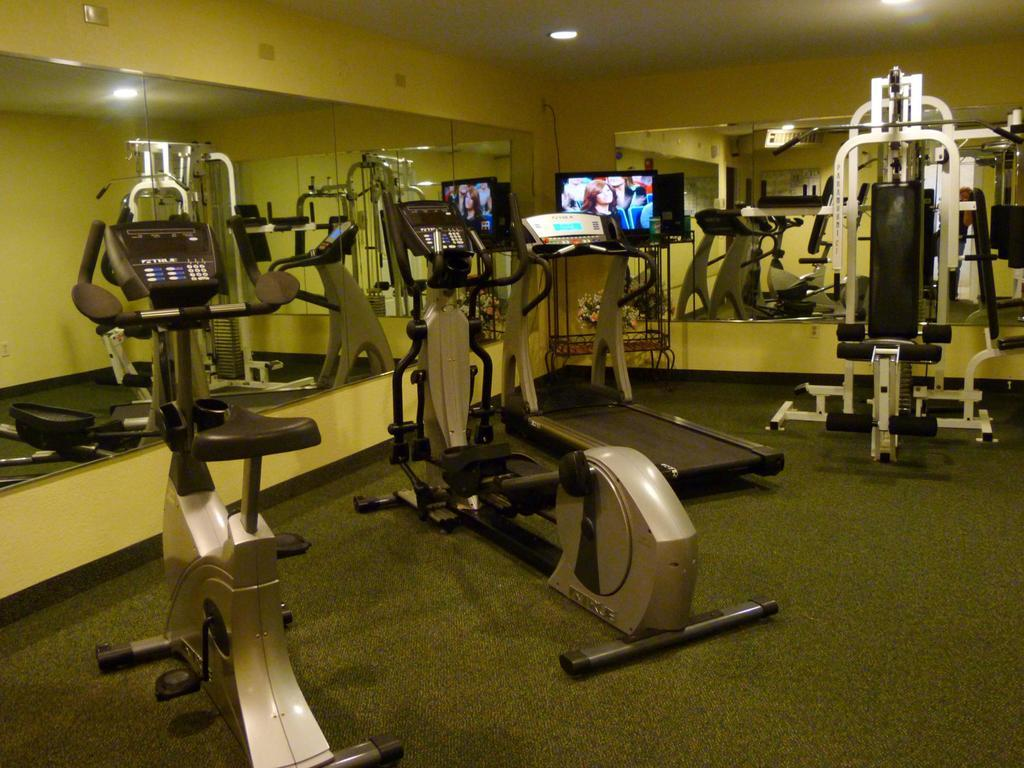What type of equipment is present in the image? There are exercise machines in the image. What electronic device can be seen in the image? There is a TV on a stand in the image. What can be used for illumination in the image? There are lights visible in the image. What feature is present on the walls in the image? There are walls with mirrors in the image. What type of watch is the person wearing in the image? There is no person wearing a watch in the image; it only features exercise machines, a TV, lights, and walls with mirrors. What kind of flame can be seen in the image? There is no flame present in the image. 